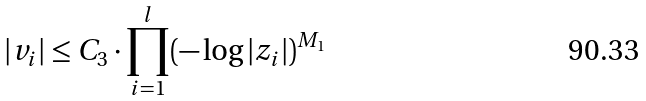Convert formula to latex. <formula><loc_0><loc_0><loc_500><loc_500>| v _ { i } | \leq C _ { 3 } \cdot \prod _ { i = 1 } ^ { l } ( - \log | z _ { i } | ) ^ { M _ { 1 } }</formula> 